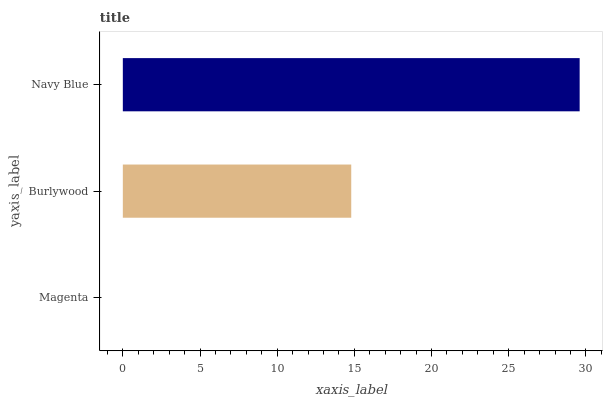Is Magenta the minimum?
Answer yes or no. Yes. Is Navy Blue the maximum?
Answer yes or no. Yes. Is Burlywood the minimum?
Answer yes or no. No. Is Burlywood the maximum?
Answer yes or no. No. Is Burlywood greater than Magenta?
Answer yes or no. Yes. Is Magenta less than Burlywood?
Answer yes or no. Yes. Is Magenta greater than Burlywood?
Answer yes or no. No. Is Burlywood less than Magenta?
Answer yes or no. No. Is Burlywood the high median?
Answer yes or no. Yes. Is Burlywood the low median?
Answer yes or no. Yes. Is Navy Blue the high median?
Answer yes or no. No. Is Navy Blue the low median?
Answer yes or no. No. 